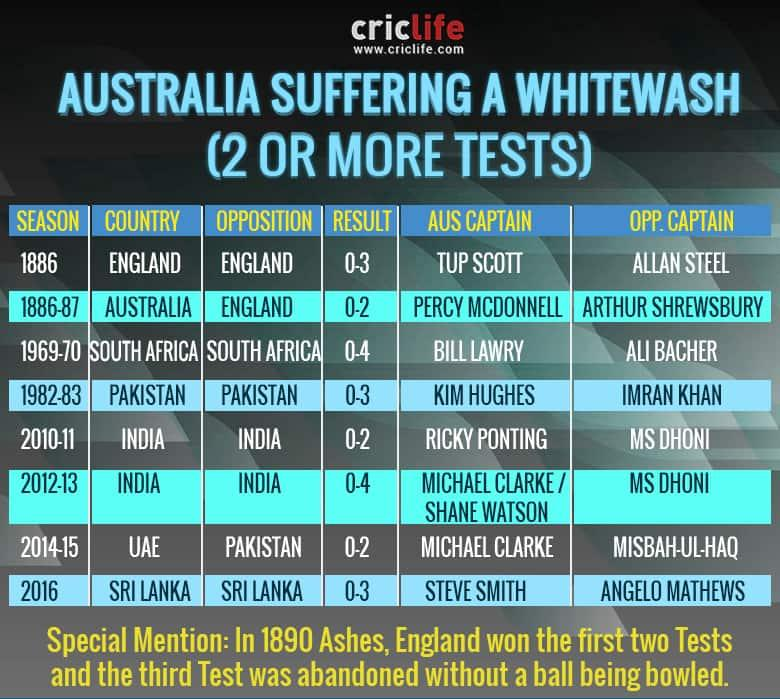Highlight a few significant elements in this photo. South Africa emerged as the winner of the test series between them and Australia in 1969-70. Ricky Ponting was the captain of Australia during the India-Australia test series in 2010-11. India emerged as the winner of the test series between India and Australia in 2012-13, defeating their opponents comprehensively. Imran Khan was the captain of the Pakistan cricket team during their test series against Australia in 1982-83. In 1886-87, the England-Australia test series was played in Australia. 